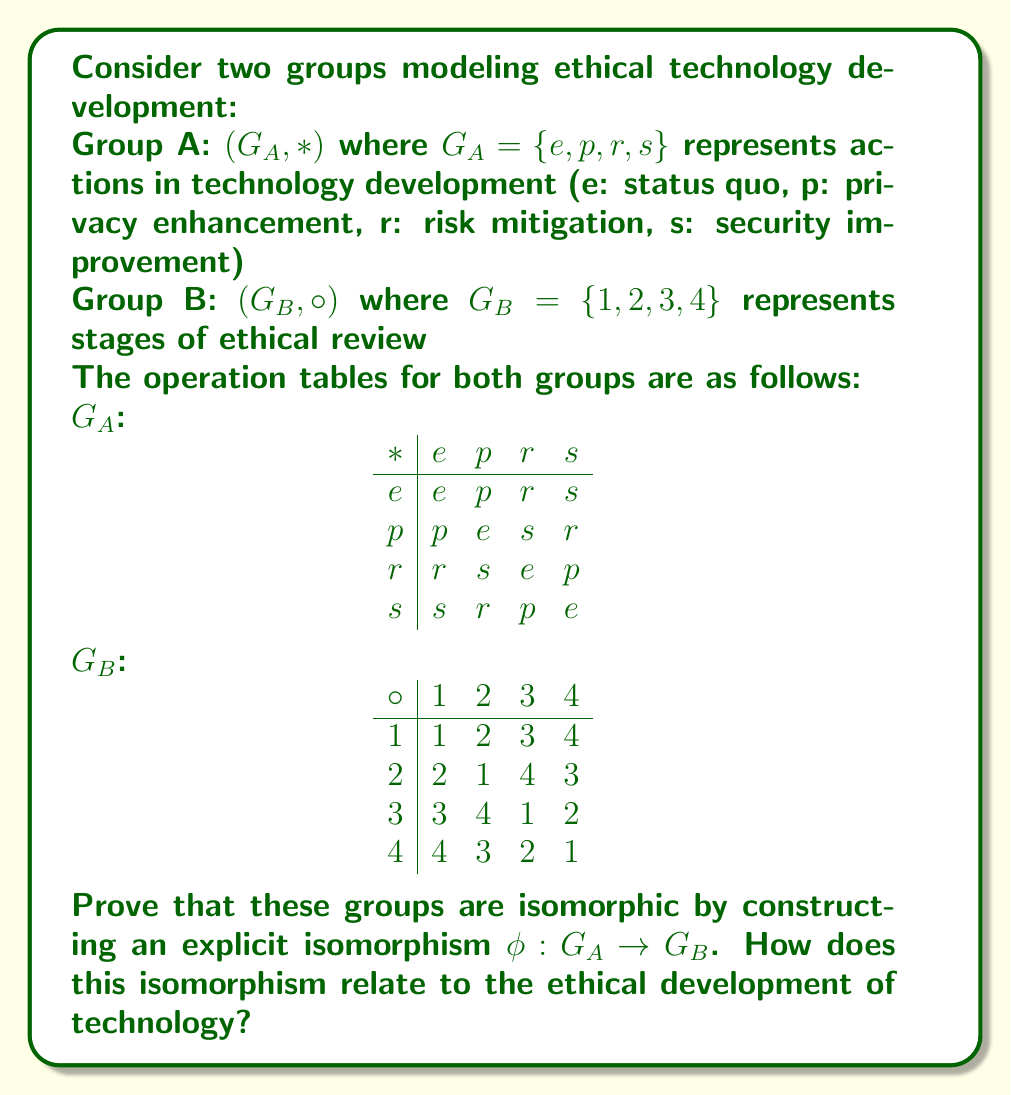Provide a solution to this math problem. To prove that the groups are isomorphic, we need to find a bijective function $\phi: G_A \to G_B$ that preserves the group operation. Let's approach this step-by-step:

1) First, we observe that both groups have the same number of elements (order 4), which is a necessary condition for isomorphism.

2) Looking at the structure of the groups, we can see that both are non-cyclic groups of order 4. In fact, they both have the structure of the Klein four-group.

3) Let's define the isomorphism $\phi: G_A \to G_B$ as follows:
   $\phi(e) = 1$
   $\phi(p) = 2$
   $\phi(r) = 3$
   $\phi(s) = 4$

4) To prove this is an isomorphism, we need to show that it's bijective and operation-preserving.

5) Bijectivity is clear from the definition: every element in $G_A$ maps to a unique element in $G_B$, and every element in $G_B$ is mapped to.

6) To show that $\phi$ preserves the operation, we need to verify that for all $a, b \in G_A$:
   $\phi(a * b) = \phi(a) \circ \phi(b)$

   Let's check a few cases:
   $\phi(p * r) = \phi(s) = 4$
   $\phi(p) \circ \phi(r) = 2 \circ 3 = 4$

   $\phi(r * s) = \phi(p) = 2$
   $\phi(r) \circ \phi(s) = 3 \circ 4 = 2$

7) Checking all possible combinations would complete the proof.

Relating this to ethical technology development:
The isomorphism shows that the structure of actions in technology development (Group A) is fundamentally the same as the structure of ethical review stages (Group B). This suggests that for every action in technology development, there's a corresponding stage in the ethical review process, and vice versa. The preservation of the group operation under this isomorphism implies that the interaction between different actions in technology development corresponds directly to the progression through stages of ethical review.

This isomorphism emphasizes the intrinsic connection between technological actions and ethical considerations, reinforcing the idea that ethical review should be an integral part of the technology development process, not an afterthought.
Answer: The groups are isomorphic under the mapping $\phi: G_A \to G_B$ defined by:
$\phi(e) = 1$, $\phi(p) = 2$, $\phi(r) = 3$, $\phi(s) = 4$

This isomorphism demonstrates the structural equivalence between actions in ethical technology development and stages of ethical review, emphasizing their intrinsic connection. 